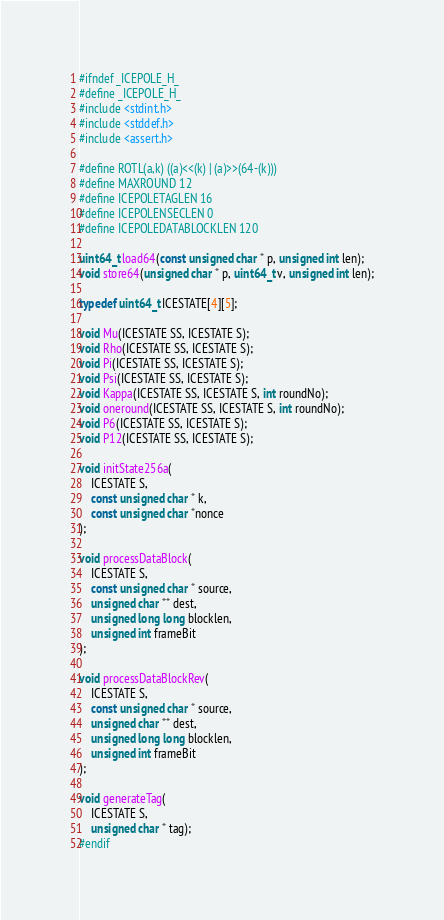Convert code to text. <code><loc_0><loc_0><loc_500><loc_500><_C_>#ifndef _ICEPOLE_H_
#define _ICEPOLE_H_
#include <stdint.h>
#include <stddef.h>
#include <assert.h>

#define ROTL(a,k) ((a)<<(k) | (a)>>(64-(k)))
#define MAXROUND 12
#define ICEPOLETAGLEN 16
#define ICEPOLENSECLEN 0
#define ICEPOLEDATABLOCKLEN 120

uint64_t load64(const unsigned char * p, unsigned int len);
void store64(unsigned char * p, uint64_t v, unsigned int len);

typedef uint64_t ICESTATE[4][5];

void Mu(ICESTATE SS, ICESTATE S);
void Rho(ICESTATE SS, ICESTATE S);
void Pi(ICESTATE SS, ICESTATE S);
void Psi(ICESTATE SS, ICESTATE S);
void Kappa(ICESTATE SS, ICESTATE S, int roundNo);
void oneround(ICESTATE SS, ICESTATE S, int roundNo);
void P6(ICESTATE SS, ICESTATE S);
void P12(ICESTATE SS, ICESTATE S);

void initState256a(
    ICESTATE S, 
    const unsigned char * k, 
    const unsigned char *nonce
);

void processDataBlock(
    ICESTATE S, 
    const unsigned char * source, 
    unsigned char ** dest,
    unsigned long long blocklen, 
    unsigned int frameBit
);

void processDataBlockRev(
    ICESTATE S, 
    const unsigned char * source, 
    unsigned char ** dest,
    unsigned long long blocklen, 
    unsigned int frameBit
);

void generateTag(
    ICESTATE S, 
    unsigned char * tag);
#endif

</code> 